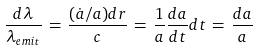<formula> <loc_0><loc_0><loc_500><loc_500>\frac { d \lambda } { \lambda _ { e m i t } } \, = \, \frac { ( \dot { a } / a ) d r } { c } \, = \, \frac { 1 } { a } \frac { d a } { d t } d t \, = \, \frac { d a } { a }</formula> 